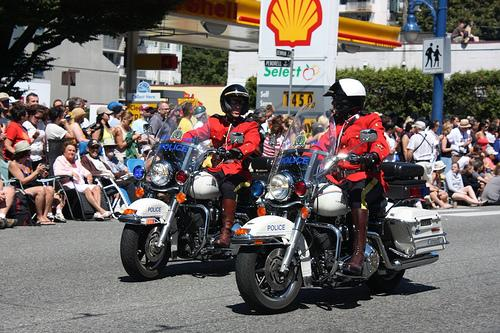Provide a brief summary of the overall setting in the image. The image captures a bustling downtown street scene with people relaxing on chairs and walls as two officers patrol on their motorcycles. Comment on the parts of the motorcycles that are visible in the image. Front wheels and fenders, headlights, and a muffler are discernible on the white motorcycles ridden by the two police officers. Describe the primary action taking place between the people and the motorcycles in the image. Two officers are riding their motorcycles past a crowd of people sitting in chairs along a street, while two people sit on a wall nearby. Mention any distinct clothing worn by the people in the image. A person in the crowd is dressed in a red jacket, while others in the image wear casual attire to sit and observe the scene. Give a brief overview of the primary scene in the image. Numerous people are sitting along a street, while two policemen on motorcycles monitor the area, and various signs and a tree are in the background. Explain the presence of the tree in the image. A large tree with green leaves is located behind the myriad of people sitting on chairs, providing shade and adding to the streetscape. Describe the streetlight and its location in the image. A blue streetlight is situated in the downtown area near the corner of the frame, towering over the scene below. Outline the various types of signs visible in the image. A Shell gas station sign, street signs behind the policemen, a white sign with black figures, and numbers on a store sign are all visible. Mention some specific details of the helmets worn by the people in the image. One of the policemen is wearing a black helmet, another is wearing a white helmet, and a person in the crowd is also wearing a white helmet. Provide a brief description of the gathering of people in the image. A large group of people are seated in lawn chairs on the street, with some sitting on a wall, as two officers ride by on their motorcycles. 